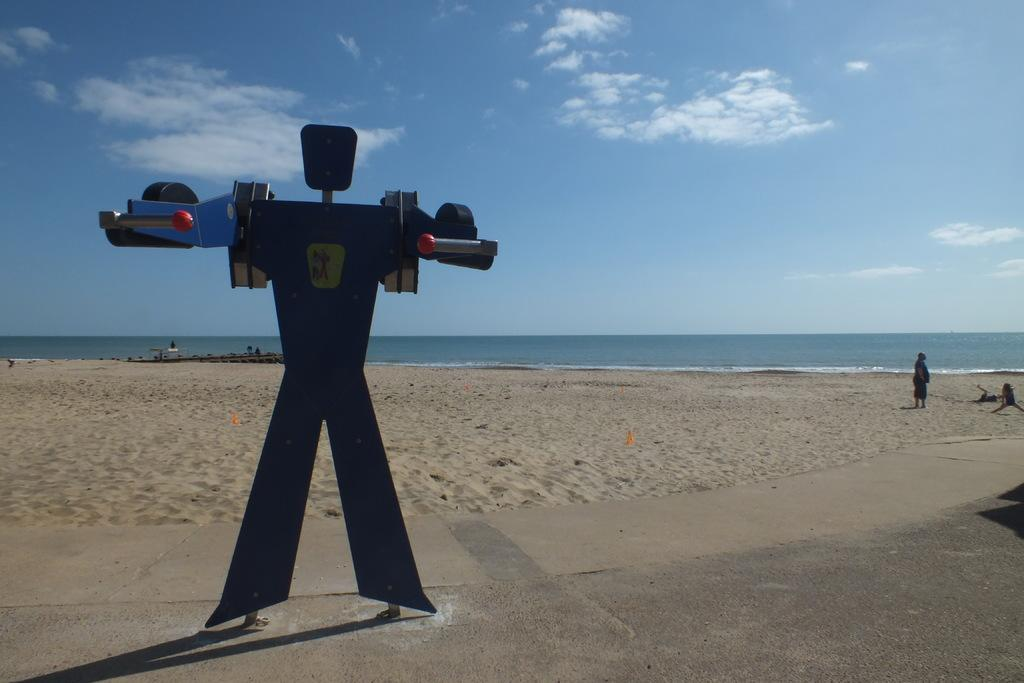What can be seen on the road in the foreground of the image? There are objects on the road in the foreground. Who is present on the beach in the foreground of the image? There are two persons on the beach in the foreground. What is visible in the background of the image? Water and the sky are visible in the background. What type of environment is depicted in the image? The image appears to be taken on a sandy beach. Can you tell me how many people are talking to each other in the image? There is no indication in the image that the two persons are talking to each other. What force is causing the water to move in the background of the image? There is no visible force causing the water to move in the background of the image; it is likely due to natural waves or tides. 